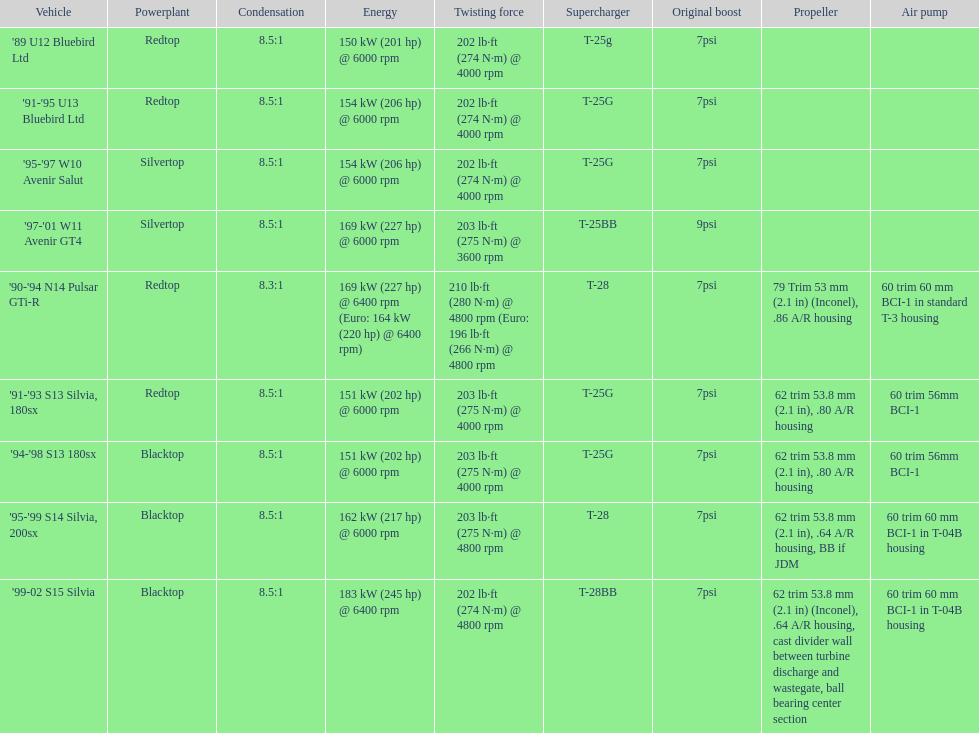Which engines are the same as the first entry ('89 u12 bluebird ltd)? '91-'95 U13 Bluebird Ltd, '90-'94 N14 Pulsar GTi-R, '91-'93 S13 Silvia, 180sx. 